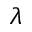Convert formula to latex. <formula><loc_0><loc_0><loc_500><loc_500>\lambda</formula> 